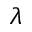Convert formula to latex. <formula><loc_0><loc_0><loc_500><loc_500>\lambda</formula> 